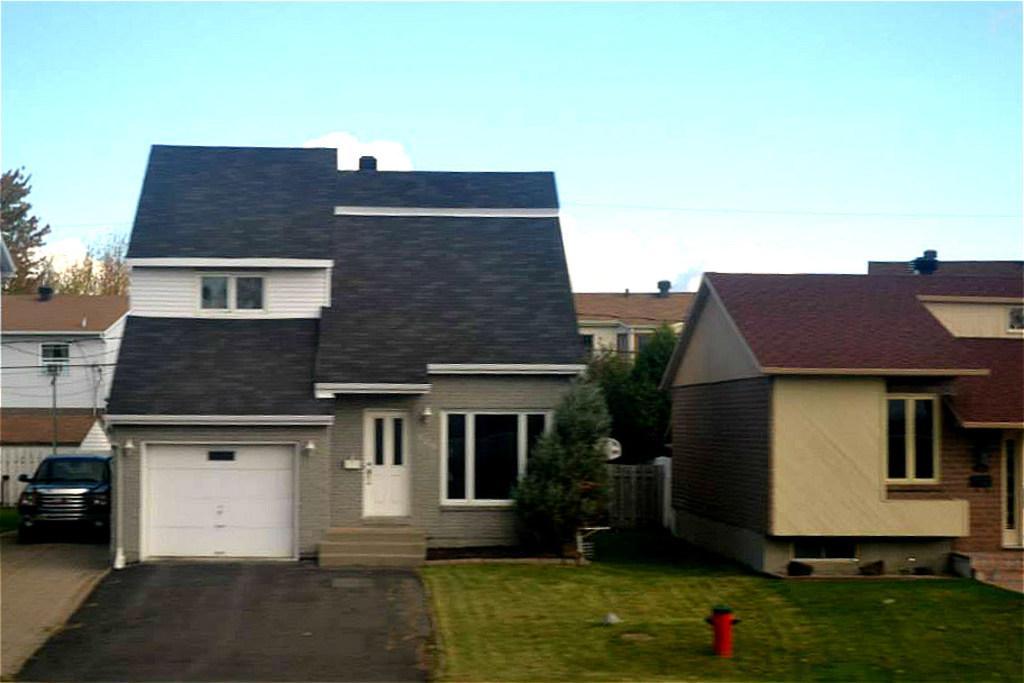Please provide a concise description of this image. In the foreground I can see a fire hydrant, grass, trees, windows, doors, houses and car on the road. In the background I can see the sky. This image is taken during a day. 